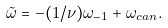<formula> <loc_0><loc_0><loc_500><loc_500>\tilde { \omega } = - ( 1 / \nu ) \omega _ { - 1 } + \omega _ { c a n } .</formula> 